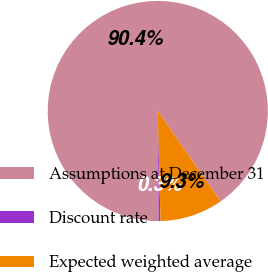<chart> <loc_0><loc_0><loc_500><loc_500><pie_chart><fcel>Assumptions at December 31<fcel>Discount rate<fcel>Expected weighted average<nl><fcel>90.44%<fcel>0.27%<fcel>9.29%<nl></chart> 